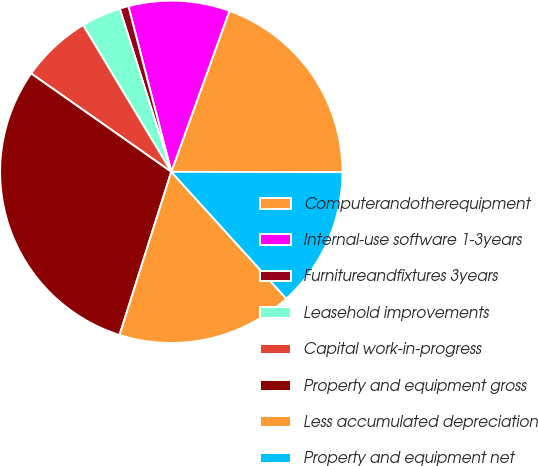Convert chart. <chart><loc_0><loc_0><loc_500><loc_500><pie_chart><fcel>Computerandotherequipment<fcel>Internal-use software 1-3years<fcel>Furnitureandfixtures 3years<fcel>Leasehold improvements<fcel>Capital work-in-progress<fcel>Property and equipment gross<fcel>Less accumulated depreciation<fcel>Property and equipment net<nl><fcel>19.51%<fcel>9.55%<fcel>0.84%<fcel>3.74%<fcel>6.65%<fcel>29.85%<fcel>16.61%<fcel>13.25%<nl></chart> 